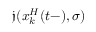<formula> <loc_0><loc_0><loc_500><loc_500>\mathfrak { j } ( x _ { k } ^ { H } ( t - ) , \sigma )</formula> 